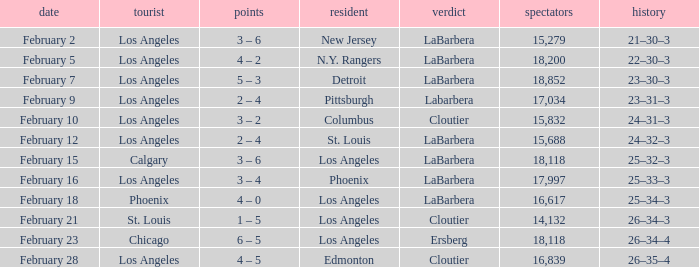What was the decision of the Kings game when Chicago was the visiting team? Ersberg. 